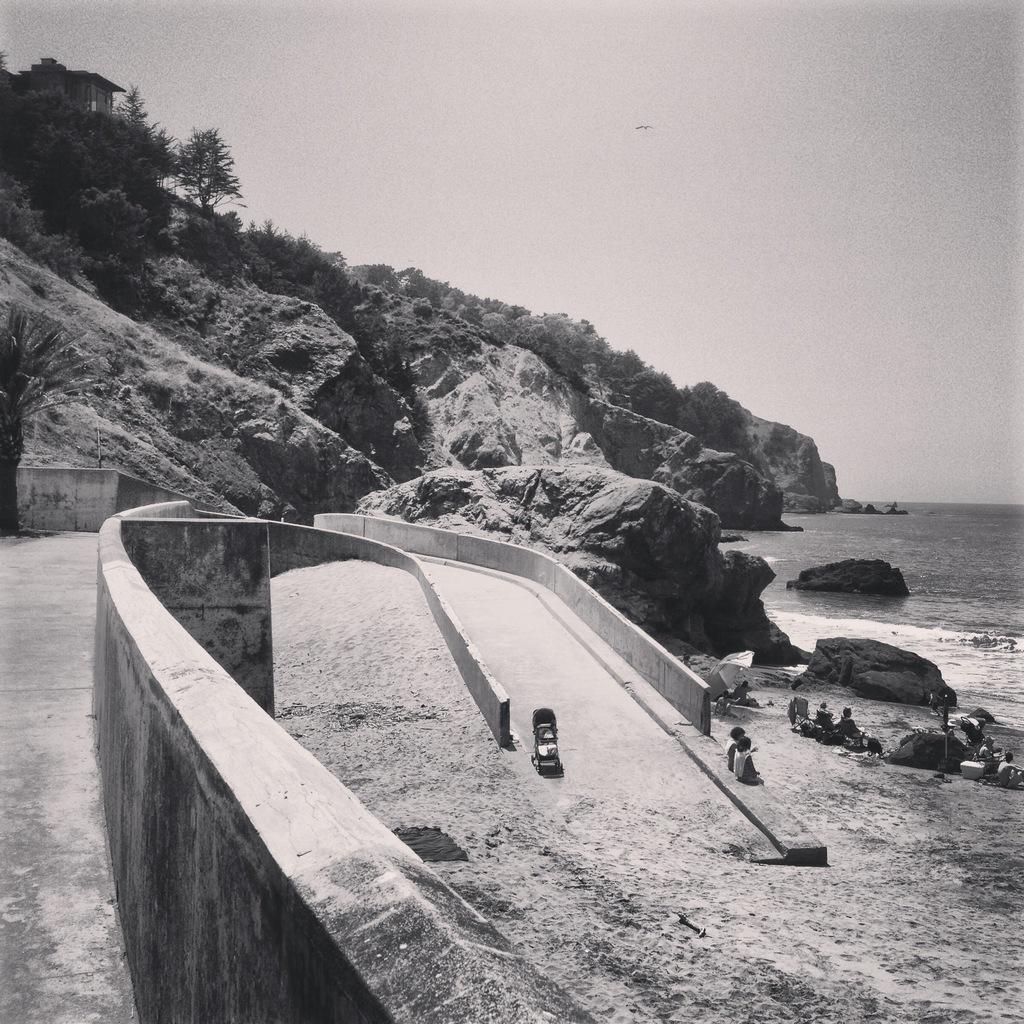What is the primary element visible in the image? There is water in the image. What type of natural landforms can be seen in the image? There are mountains in the image. What type of vegetation is present in the image? There are trees in the image. What type of man-made structure is visible in the image? There is a wall in the image. Where are the people located in the image? The people are sitting on the right side of the image. Can you tell me how many times the governor jumps in the image? There is no governor present in the image, and therefore no jumping can be observed. 